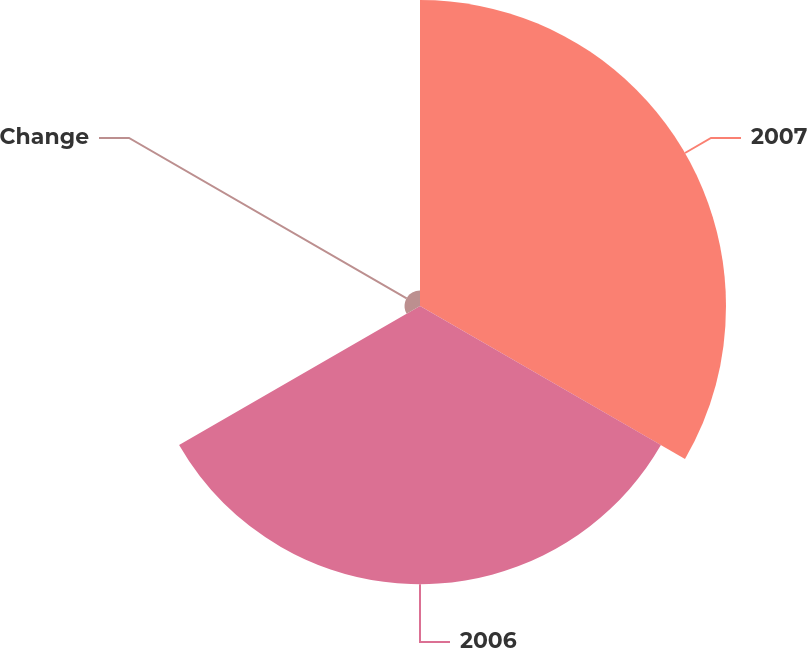Convert chart to OTSL. <chart><loc_0><loc_0><loc_500><loc_500><pie_chart><fcel>2007<fcel>2006<fcel>Change<nl><fcel>51.03%<fcel>46.39%<fcel>2.58%<nl></chart> 